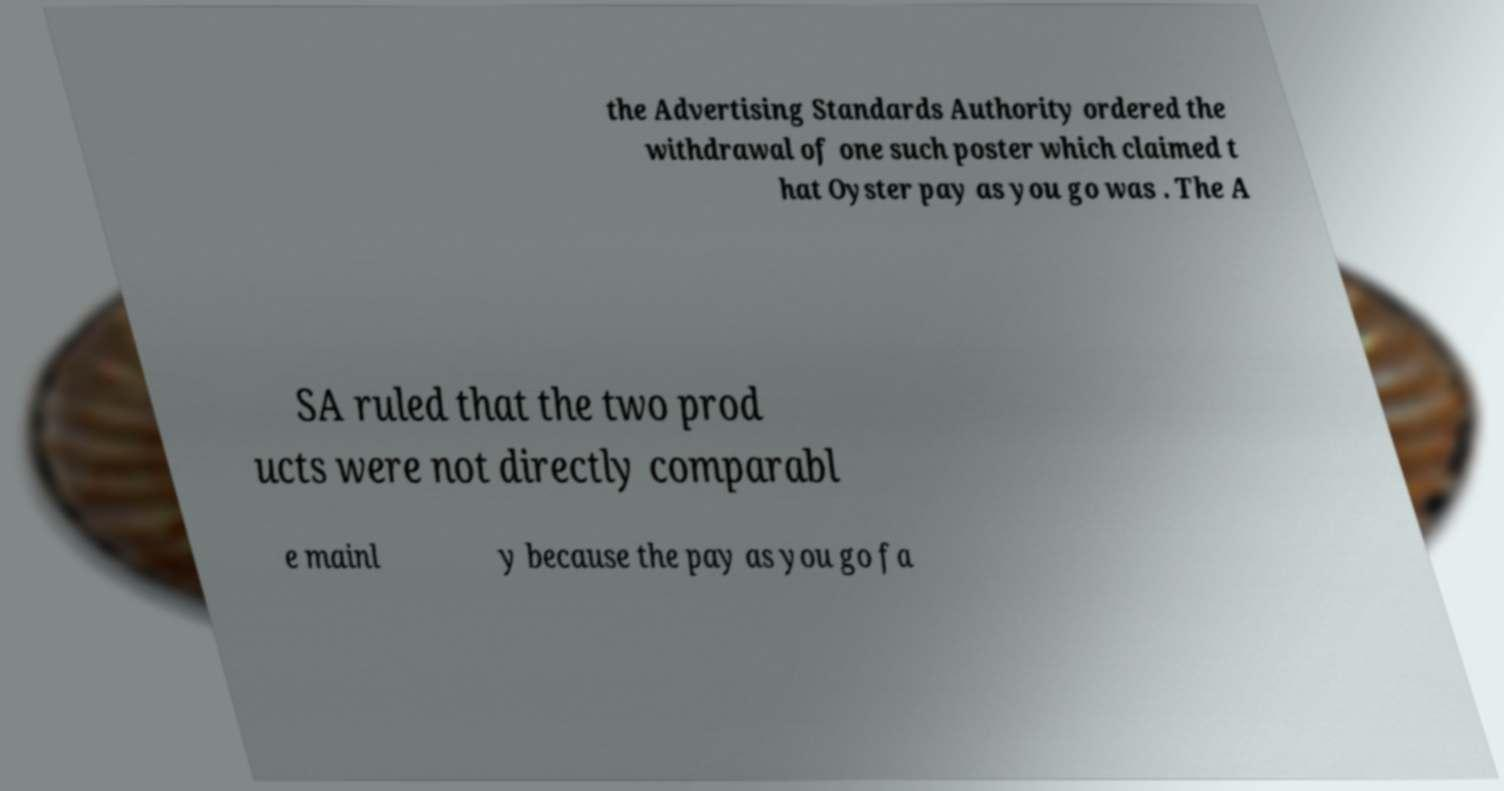Can you accurately transcribe the text from the provided image for me? the Advertising Standards Authority ordered the withdrawal of one such poster which claimed t hat Oyster pay as you go was . The A SA ruled that the two prod ucts were not directly comparabl e mainl y because the pay as you go fa 